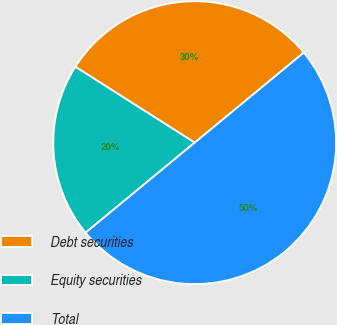Convert chart to OTSL. <chart><loc_0><loc_0><loc_500><loc_500><pie_chart><fcel>Debt securities<fcel>Equity securities<fcel>Total<nl><fcel>30.0%<fcel>20.0%<fcel>50.0%<nl></chart> 